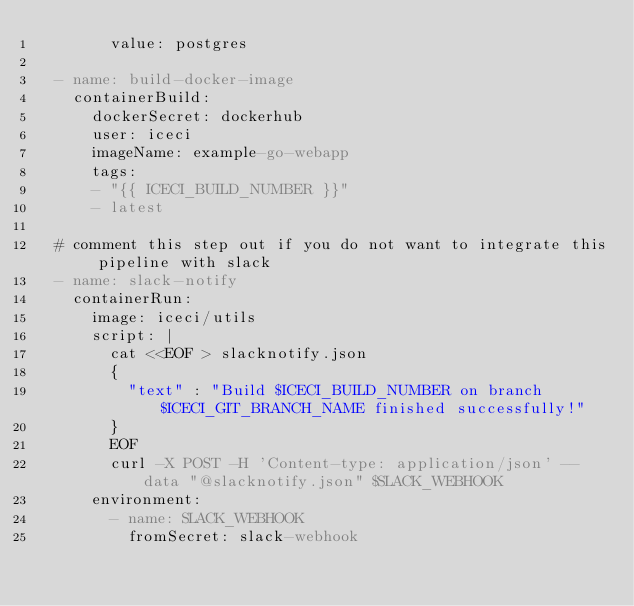Convert code to text. <code><loc_0><loc_0><loc_500><loc_500><_YAML_>        value: postgres

  - name: build-docker-image
    containerBuild:
      dockerSecret: dockerhub
      user: iceci
      imageName: example-go-webapp
      tags:
      - "{{ ICECI_BUILD_NUMBER }}"
      - latest

  # comment this step out if you do not want to integrate this pipeline with slack
  - name: slack-notify
    containerRun:
      image: iceci/utils
      script: |
        cat <<EOF > slacknotify.json
        {
          "text" : "Build $ICECI_BUILD_NUMBER on branch $ICECI_GIT_BRANCH_NAME finished successfully!"
        }
        EOF
        curl -X POST -H 'Content-type: application/json' --data "@slacknotify.json" $SLACK_WEBHOOK
      environment:
        - name: SLACK_WEBHOOK
          fromSecret: slack-webhook
</code> 